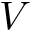Convert formula to latex. <formula><loc_0><loc_0><loc_500><loc_500>V</formula> 